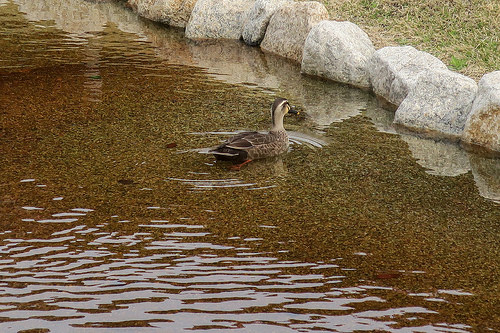<image>
Can you confirm if the rocks is above the water? No. The rocks is not positioned above the water. The vertical arrangement shows a different relationship. 